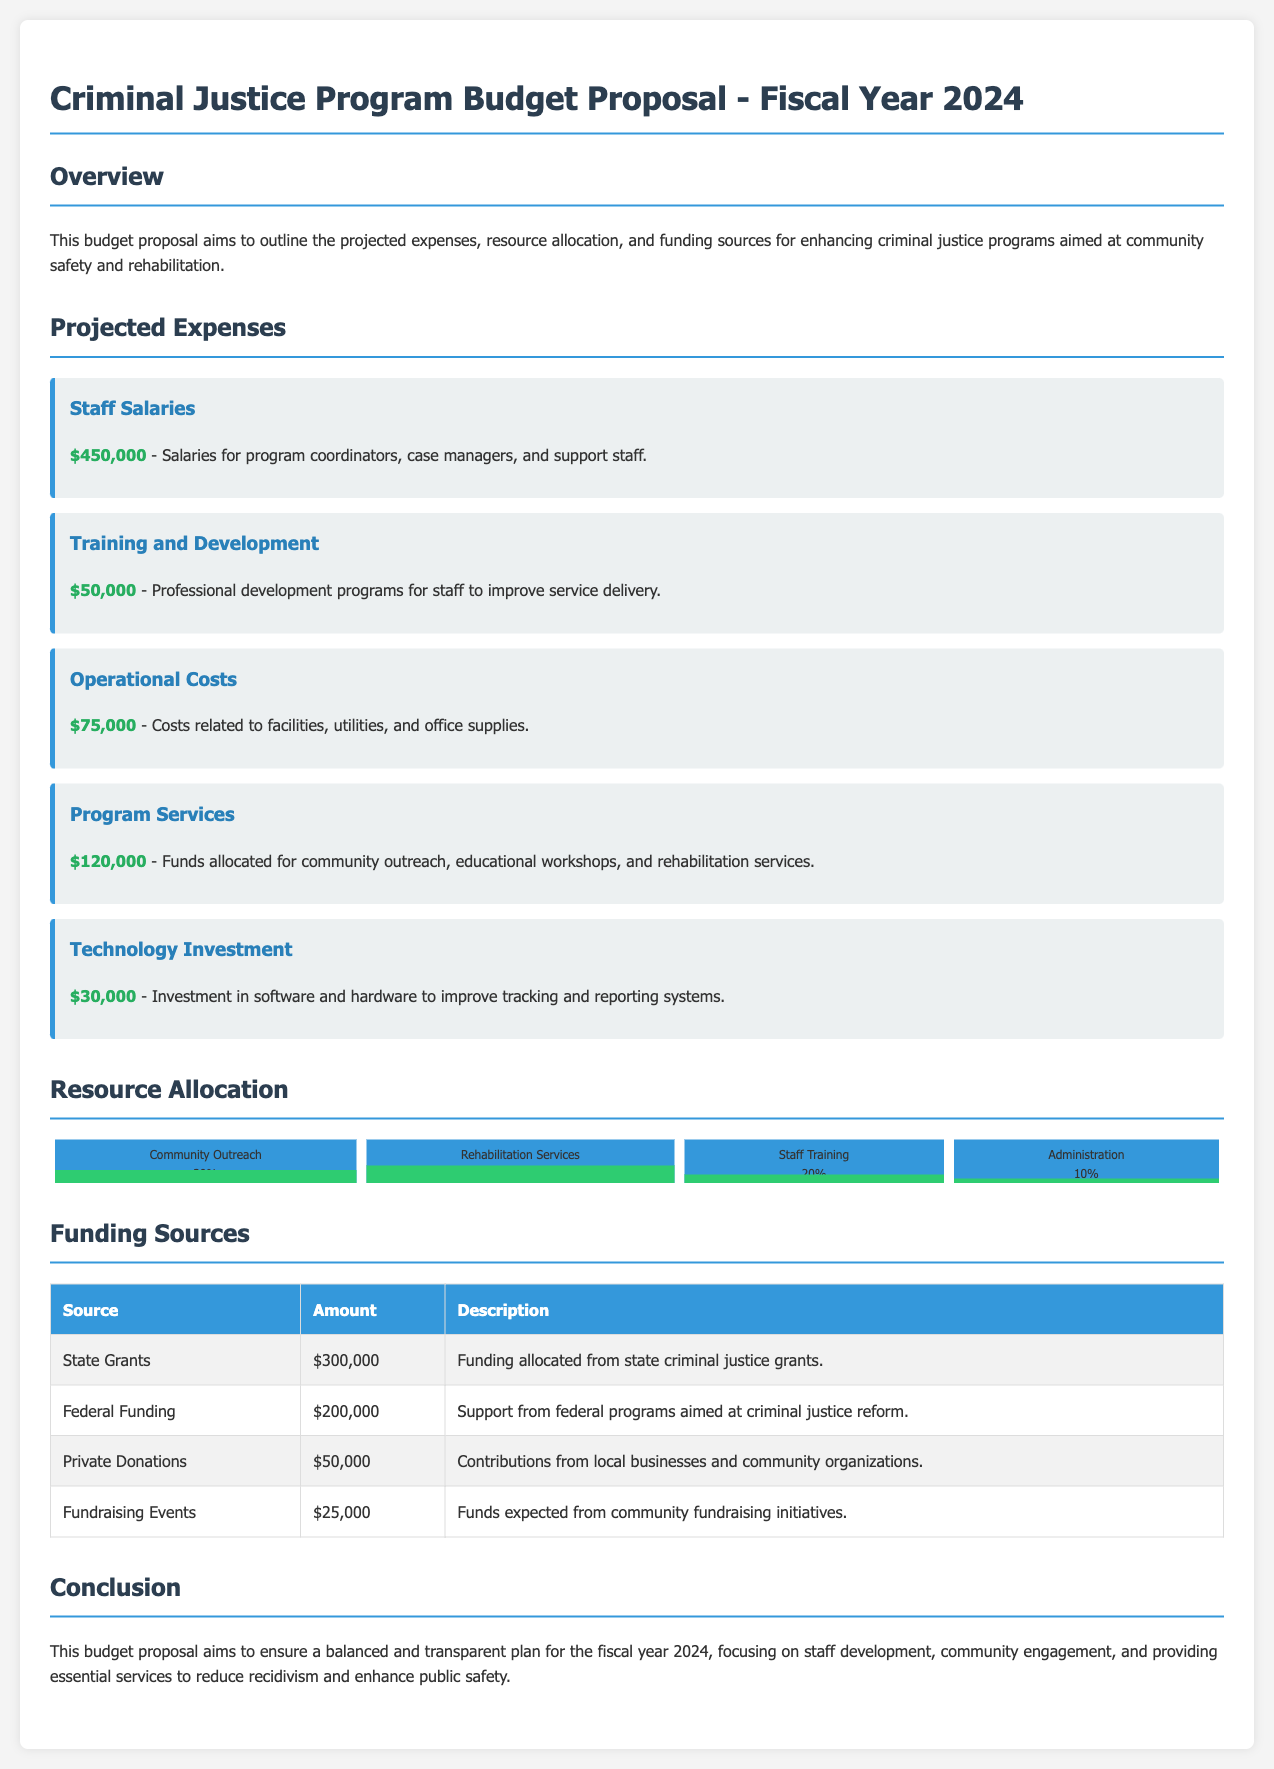What is the total projected expense for Staff Salaries? The specific section mentions the total projected expense for Staff Salaries is $450,000.
Answer: $450,000 What percentage of the budget is allocated to Rehabilitation Services? The chart shows that Rehabilitation Services account for 40% of the resource allocation.
Answer: 40% How much is planned for Training and Development? The document specifies that $50,000 is allocated for Training and Development.
Answer: $50,000 What is the amount from Federal Funding? The Funding Sources table indicates that the amount from Federal Funding is $200,000.
Answer: $200,000 What is the combined total from State Grants and Private Donations? The combined total is calculated by adding $300,000 from State Grants and $50,000 from Private Donations, resulting in $350,000.
Answer: $350,000 What is the total budget for Program Services? Program Services is allocated $120,000 as per the projected expenses section.
Answer: $120,000 What is the purpose of the document? The document outlines projected expenses, resource allocation, and funding sources for criminal justice programs.
Answer: Budget proposal How much is allocated for Operational Costs? The document indicates that Operational Costs are allocated $75,000.
Answer: $75,000 What is the total amount expected from Fundraising Events? The Funding Sources table states that the expected amount from Fundraising Events is $25,000.
Answer: $25,000 